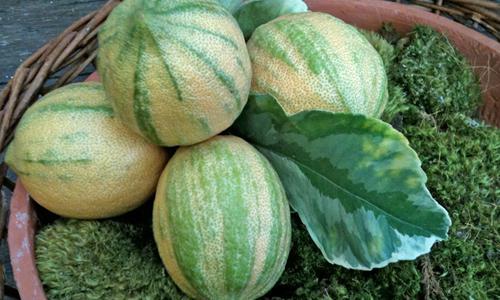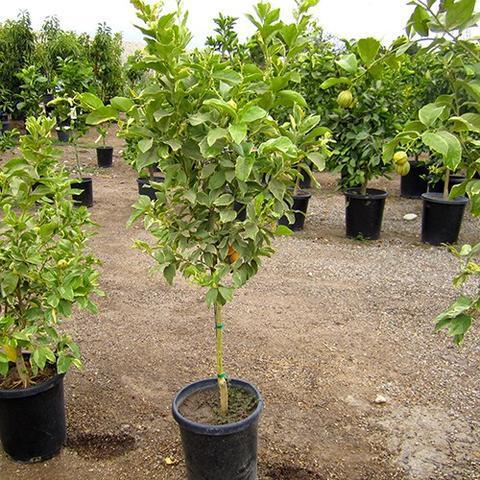The first image is the image on the left, the second image is the image on the right. Assess this claim about the two images: "There are lemon trees in both images.". Correct or not? Answer yes or no. No. 